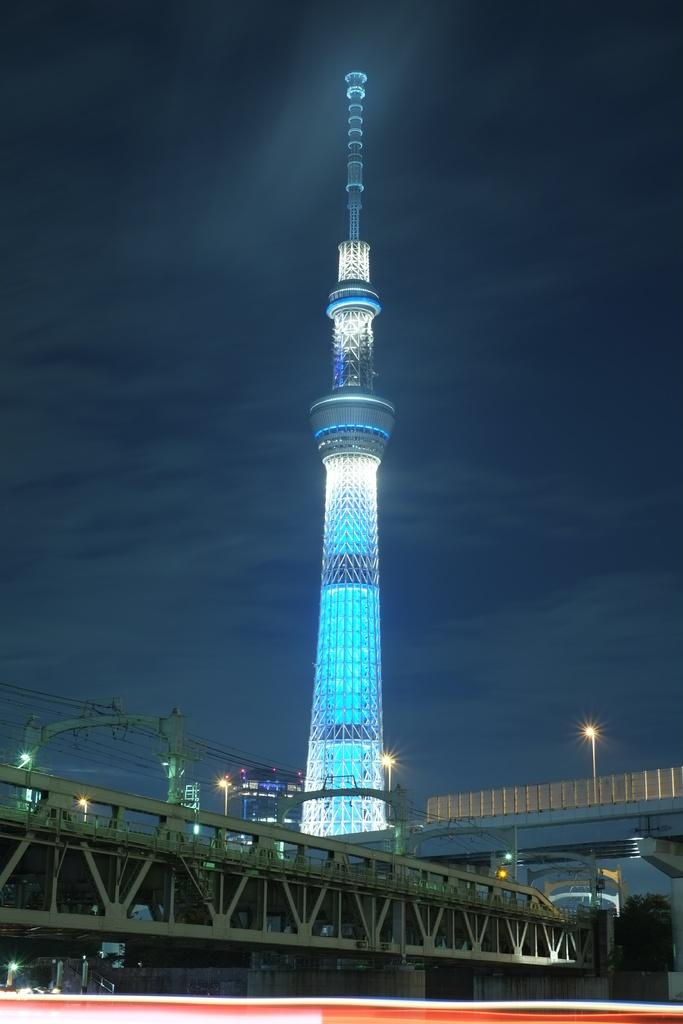What type of structure can be seen in the image? There is a bridge in the image. What other structure is present in the image? There is a tower in the image. What can be seen illuminating the area in the image? There are lights in the image. What supports the lights in the image? There are poles in the image. What type of plant is visible in the image? There is a tree in the image. What is visible in the background of the image? The sky with clouds is visible in the background of the image. Who is the creator of the boats seen in the image? There are no boats present in the image, so it is not possible to determine the creator. 